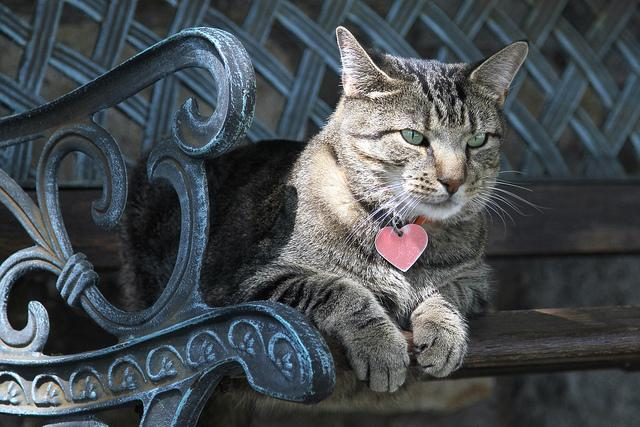What is the purpose of the heart around the cats neck?

Choices:
A) protection
B) visibility
C) fashion
D) identification identification 